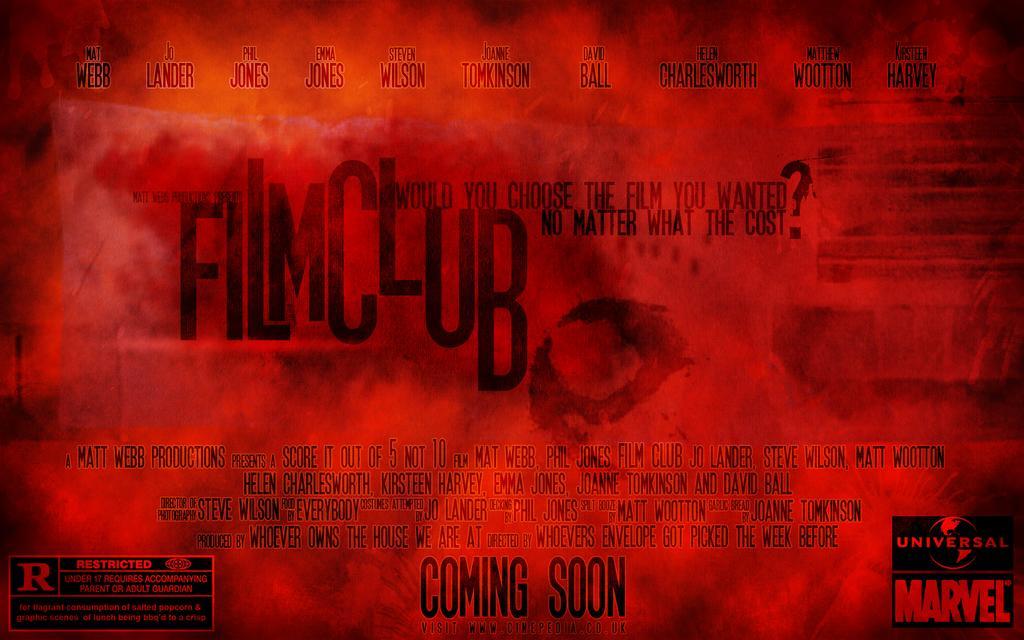Can you describe this image briefly? In the image in the center we can see one poster. On the poster,we can see something written on it. 